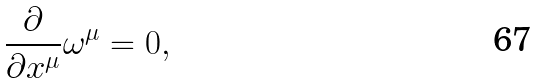Convert formula to latex. <formula><loc_0><loc_0><loc_500><loc_500>\frac { \partial } { \partial x ^ { \mu } } \omega ^ { \mu } = 0 ,</formula> 